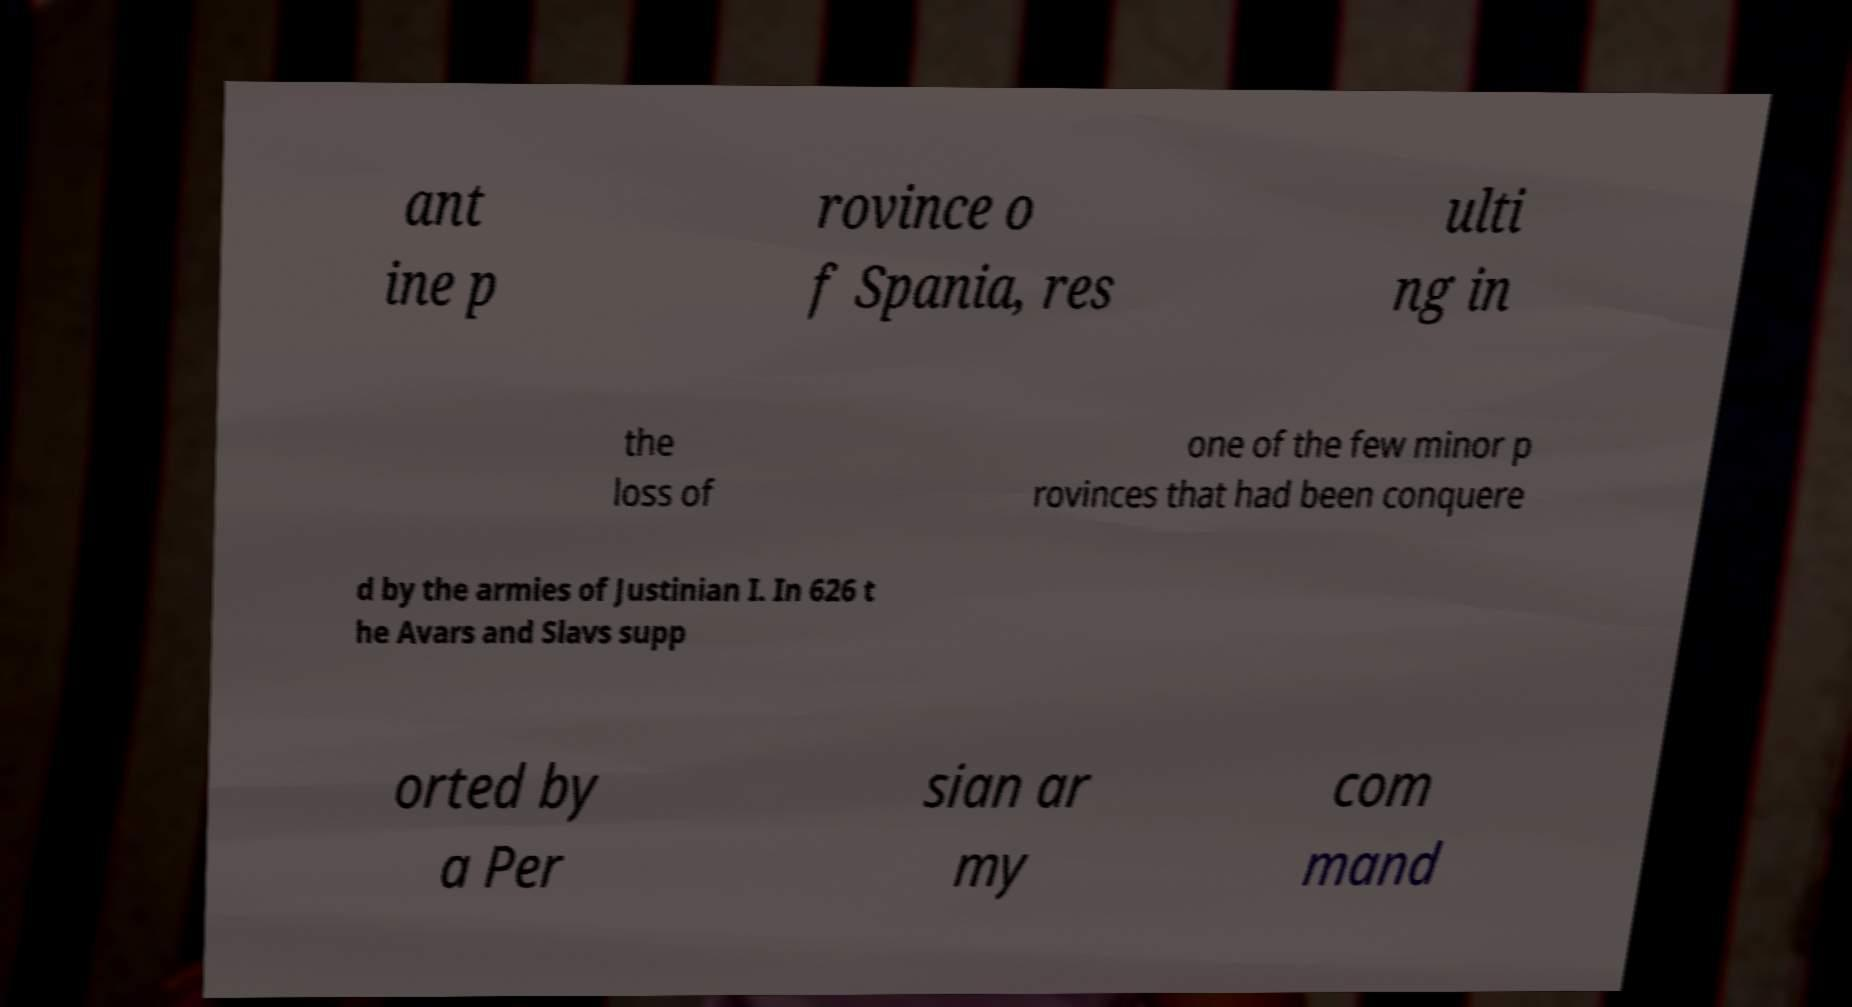There's text embedded in this image that I need extracted. Can you transcribe it verbatim? ant ine p rovince o f Spania, res ulti ng in the loss of one of the few minor p rovinces that had been conquere d by the armies of Justinian I. In 626 t he Avars and Slavs supp orted by a Per sian ar my com mand 